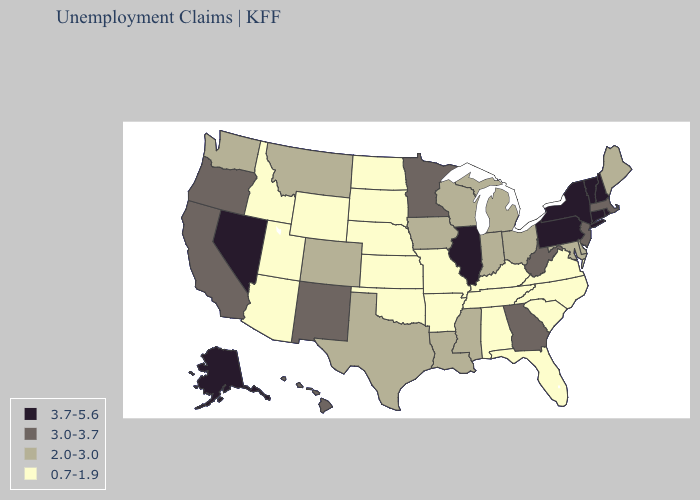What is the highest value in the USA?
Be succinct. 3.7-5.6. Does North Carolina have the lowest value in the South?
Concise answer only. Yes. How many symbols are there in the legend?
Short answer required. 4. Name the states that have a value in the range 3.7-5.6?
Short answer required. Alaska, Connecticut, Illinois, Nevada, New Hampshire, New York, Pennsylvania, Rhode Island, Vermont. Which states have the lowest value in the South?
Write a very short answer. Alabama, Arkansas, Florida, Kentucky, North Carolina, Oklahoma, South Carolina, Tennessee, Virginia. Name the states that have a value in the range 2.0-3.0?
Be succinct. Colorado, Delaware, Indiana, Iowa, Louisiana, Maine, Maryland, Michigan, Mississippi, Montana, Ohio, Texas, Washington, Wisconsin. What is the highest value in states that border New York?
Answer briefly. 3.7-5.6. What is the highest value in the USA?
Write a very short answer. 3.7-5.6. Among the states that border Utah , which have the lowest value?
Give a very brief answer. Arizona, Idaho, Wyoming. Does Mississippi have the same value as New Mexico?
Keep it brief. No. Name the states that have a value in the range 3.0-3.7?
Concise answer only. California, Georgia, Hawaii, Massachusetts, Minnesota, New Jersey, New Mexico, Oregon, West Virginia. Among the states that border Missouri , which have the lowest value?
Write a very short answer. Arkansas, Kansas, Kentucky, Nebraska, Oklahoma, Tennessee. What is the value of Nevada?
Write a very short answer. 3.7-5.6. Does Arizona have a lower value than Nebraska?
Concise answer only. No. What is the value of Connecticut?
Give a very brief answer. 3.7-5.6. 